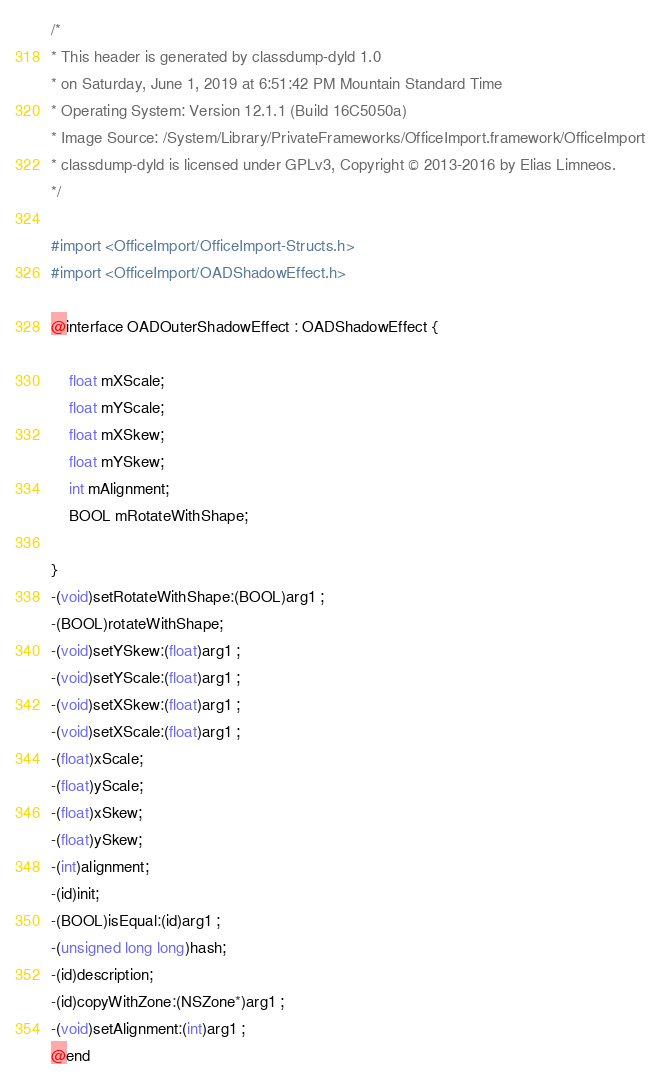<code> <loc_0><loc_0><loc_500><loc_500><_C_>/*
* This header is generated by classdump-dyld 1.0
* on Saturday, June 1, 2019 at 6:51:42 PM Mountain Standard Time
* Operating System: Version 12.1.1 (Build 16C5050a)
* Image Source: /System/Library/PrivateFrameworks/OfficeImport.framework/OfficeImport
* classdump-dyld is licensed under GPLv3, Copyright © 2013-2016 by Elias Limneos.
*/

#import <OfficeImport/OfficeImport-Structs.h>
#import <OfficeImport/OADShadowEffect.h>

@interface OADOuterShadowEffect : OADShadowEffect {

	float mXScale;
	float mYScale;
	float mXSkew;
	float mYSkew;
	int mAlignment;
	BOOL mRotateWithShape;

}
-(void)setRotateWithShape:(BOOL)arg1 ;
-(BOOL)rotateWithShape;
-(void)setYSkew:(float)arg1 ;
-(void)setYScale:(float)arg1 ;
-(void)setXSkew:(float)arg1 ;
-(void)setXScale:(float)arg1 ;
-(float)xScale;
-(float)yScale;
-(float)xSkew;
-(float)ySkew;
-(int)alignment;
-(id)init;
-(BOOL)isEqual:(id)arg1 ;
-(unsigned long long)hash;
-(id)description;
-(id)copyWithZone:(NSZone*)arg1 ;
-(void)setAlignment:(int)arg1 ;
@end

</code> 